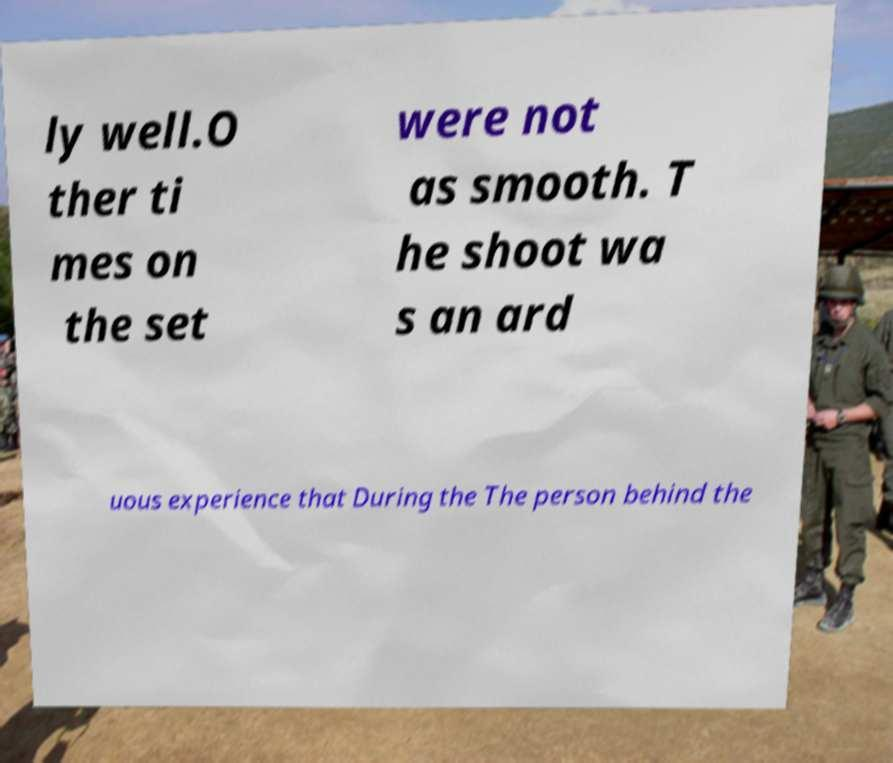Please read and relay the text visible in this image. What does it say? ly well.O ther ti mes on the set were not as smooth. T he shoot wa s an ard uous experience that During the The person behind the 